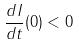Convert formula to latex. <formula><loc_0><loc_0><loc_500><loc_500>\frac { d I } { d t } ( 0 ) < 0</formula> 